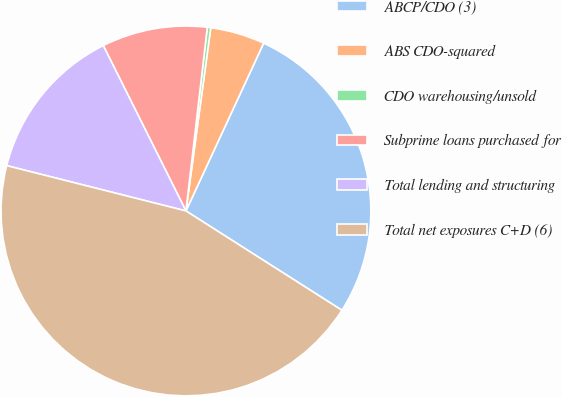<chart> <loc_0><loc_0><loc_500><loc_500><pie_chart><fcel>ABCP/CDO (3)<fcel>ABS CDO-squared<fcel>CDO warehousing/unsold<fcel>Subprime loans purchased for<fcel>Total lending and structuring<fcel>Total net exposures C+D (6)<nl><fcel>27.12%<fcel>4.76%<fcel>0.3%<fcel>9.22%<fcel>13.68%<fcel>44.91%<nl></chart> 